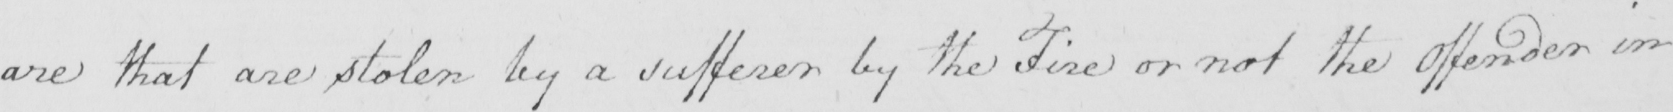Can you read and transcribe this handwriting? are that are stolen by a sufferer by the Fire or not the Offender in 